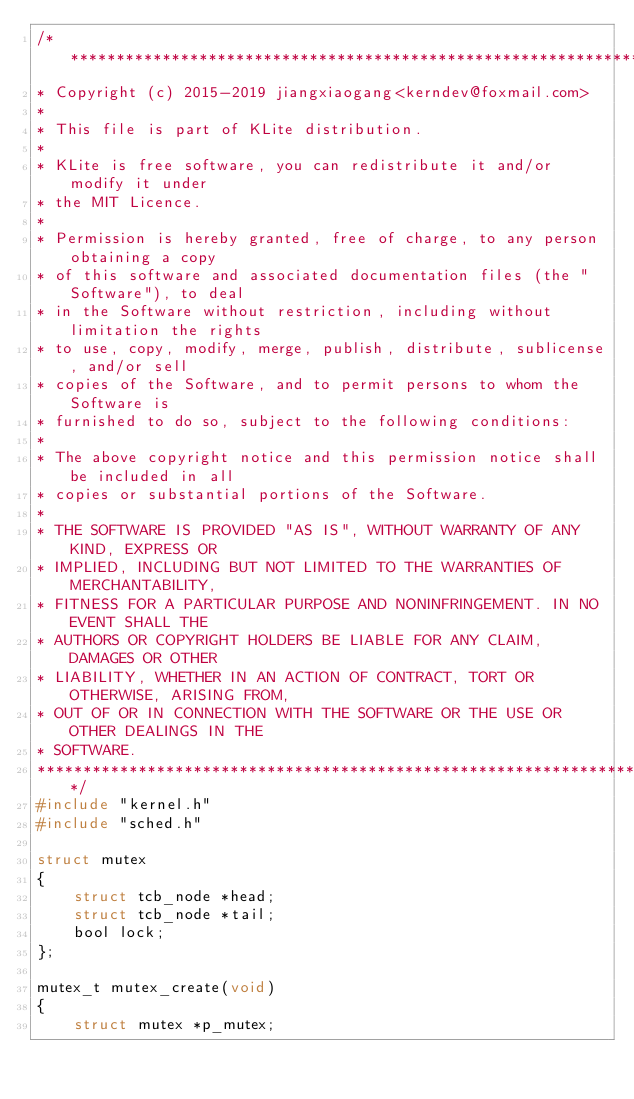<code> <loc_0><loc_0><loc_500><loc_500><_C_>/******************************************************************************
* Copyright (c) 2015-2019 jiangxiaogang<kerndev@foxmail.com>
*
* This file is part of KLite distribution.
*
* KLite is free software, you can redistribute it and/or modify it under
* the MIT Licence.
*
* Permission is hereby granted, free of charge, to any person obtaining a copy
* of this software and associated documentation files (the "Software"), to deal
* in the Software without restriction, including without limitation the rights
* to use, copy, modify, merge, publish, distribute, sublicense, and/or sell
* copies of the Software, and to permit persons to whom the Software is
* furnished to do so, subject to the following conditions:
* 
* The above copyright notice and this permission notice shall be included in all
* copies or substantial portions of the Software.
* 
* THE SOFTWARE IS PROVIDED "AS IS", WITHOUT WARRANTY OF ANY KIND, EXPRESS OR
* IMPLIED, INCLUDING BUT NOT LIMITED TO THE WARRANTIES OF MERCHANTABILITY,
* FITNESS FOR A PARTICULAR PURPOSE AND NONINFRINGEMENT. IN NO EVENT SHALL THE
* AUTHORS OR COPYRIGHT HOLDERS BE LIABLE FOR ANY CLAIM, DAMAGES OR OTHER
* LIABILITY, WHETHER IN AN ACTION OF CONTRACT, TORT OR OTHERWISE, ARISING FROM,
* OUT OF OR IN CONNECTION WITH THE SOFTWARE OR THE USE OR OTHER DEALINGS IN THE
* SOFTWARE.
******************************************************************************/
#include "kernel.h"
#include "sched.h"

struct mutex
{
    struct tcb_node *head;
    struct tcb_node *tail;
    bool lock;
};

mutex_t mutex_create(void)
{
    struct mutex *p_mutex;</code> 